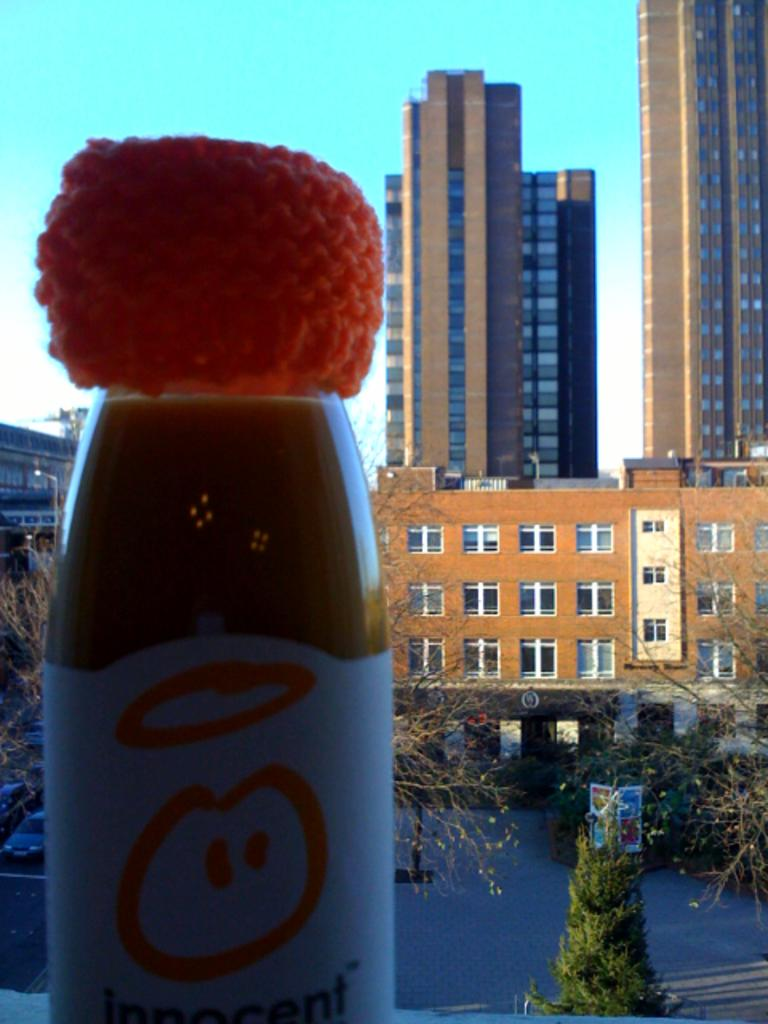What object is located in the foreground of the image? There is a glass bottle in the foreground of the image. What type of structures can be seen in the background of the image? There are high-story buildings in the background of the image. What type of vegetation is visible in the background of the image? There are trees in the background of the image. What type of stamp can be seen on the glass bottle in the image? There is no stamp visible on the glass bottle in the image. What type of pest is crawling on the trees in the background of the image? There is no pest visible on the trees in the background of the image. 